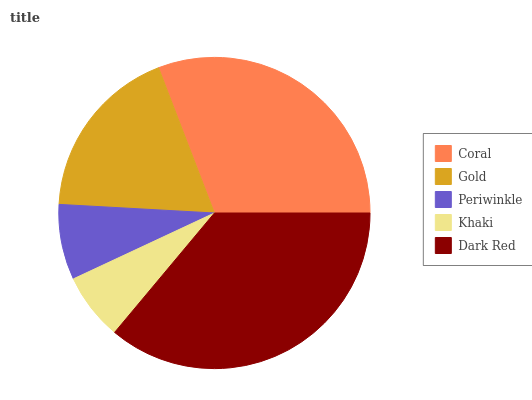Is Khaki the minimum?
Answer yes or no. Yes. Is Dark Red the maximum?
Answer yes or no. Yes. Is Gold the minimum?
Answer yes or no. No. Is Gold the maximum?
Answer yes or no. No. Is Coral greater than Gold?
Answer yes or no. Yes. Is Gold less than Coral?
Answer yes or no. Yes. Is Gold greater than Coral?
Answer yes or no. No. Is Coral less than Gold?
Answer yes or no. No. Is Gold the high median?
Answer yes or no. Yes. Is Gold the low median?
Answer yes or no. Yes. Is Coral the high median?
Answer yes or no. No. Is Coral the low median?
Answer yes or no. No. 